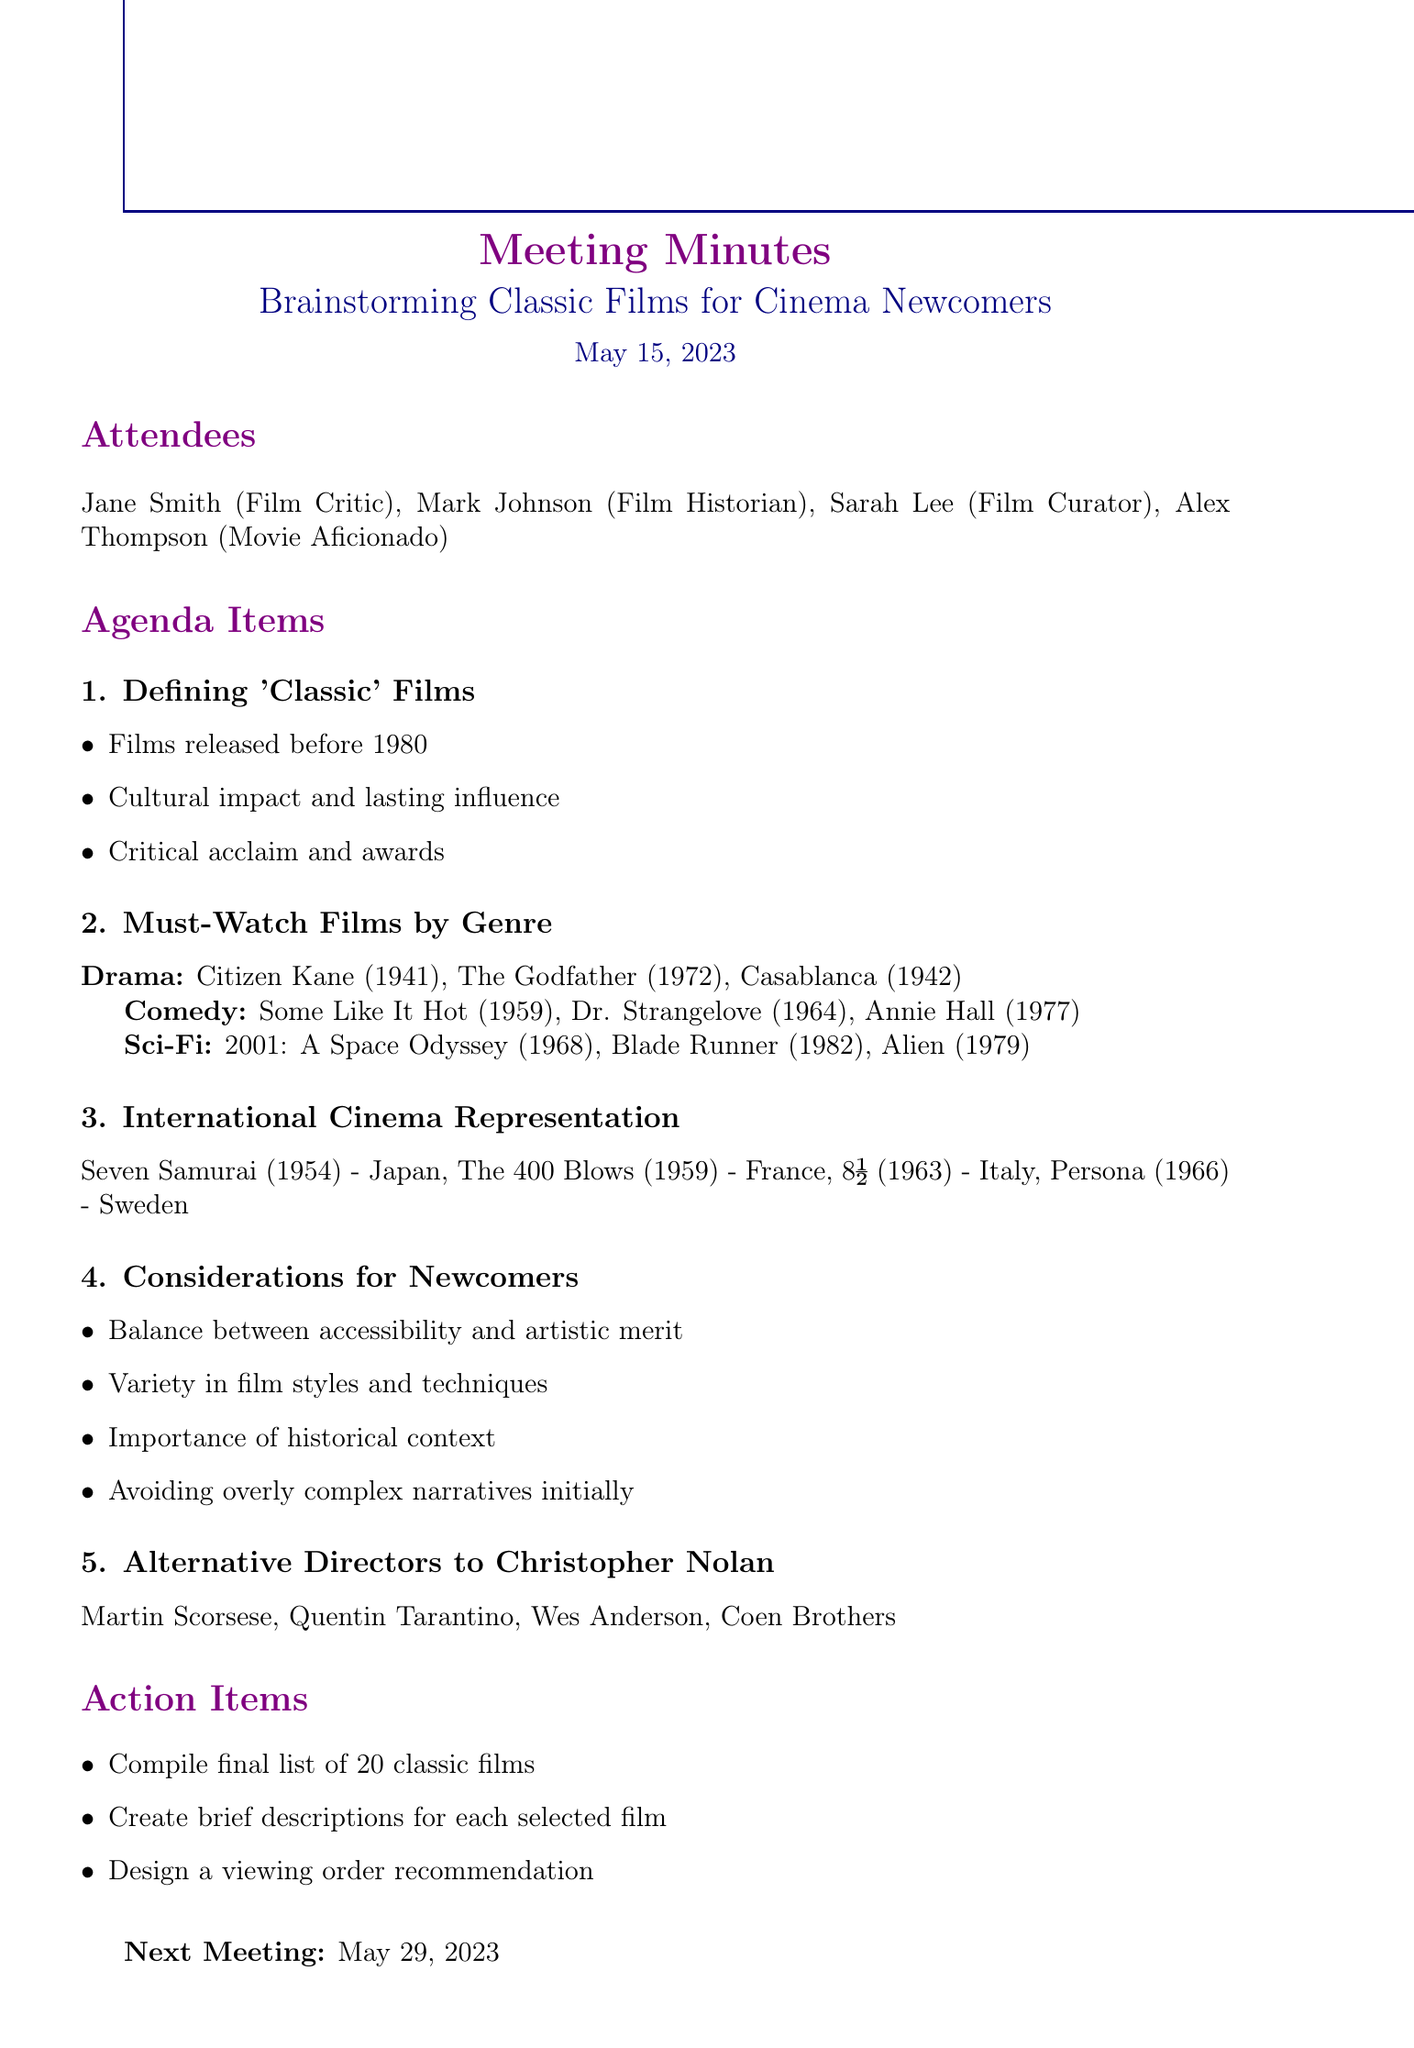What is the date of the meeting? The date of the meeting is mentioned in the document as May 15, 2023.
Answer: May 15, 2023 Who are the attendees? The document lists four attendees with their roles.
Answer: Jane Smith, Mark Johnson, Sarah Lee, Alex Thompson What is one aspect of defining 'classic' films? The document outlines three specific discussion points, one of which is cultural impact and lasting influence.
Answer: Cultural impact Name a suggested film in the Comedy genre. The document lists films under different genres, including comedy suggestions like "Some Like It Hot."
Answer: Some Like It Hot What is one consideration for newcomers? The document provides multiple considerations, one being the balance between accessibility and artistic merit.
Answer: Accessibility What is the final action item listed in the document? The last action item mentioned in the minutes is to design a viewing order recommendation.
Answer: Design a viewing order recommendation When is the next meeting scheduled? The document specifies the date of the next meeting clearly as May 29, 2023.
Answer: May 29, 2023 List one alternative director to Christopher Nolan. The document provides a list of alternative directors, one of which is Martin Scorsese.
Answer: Martin Scorsese 